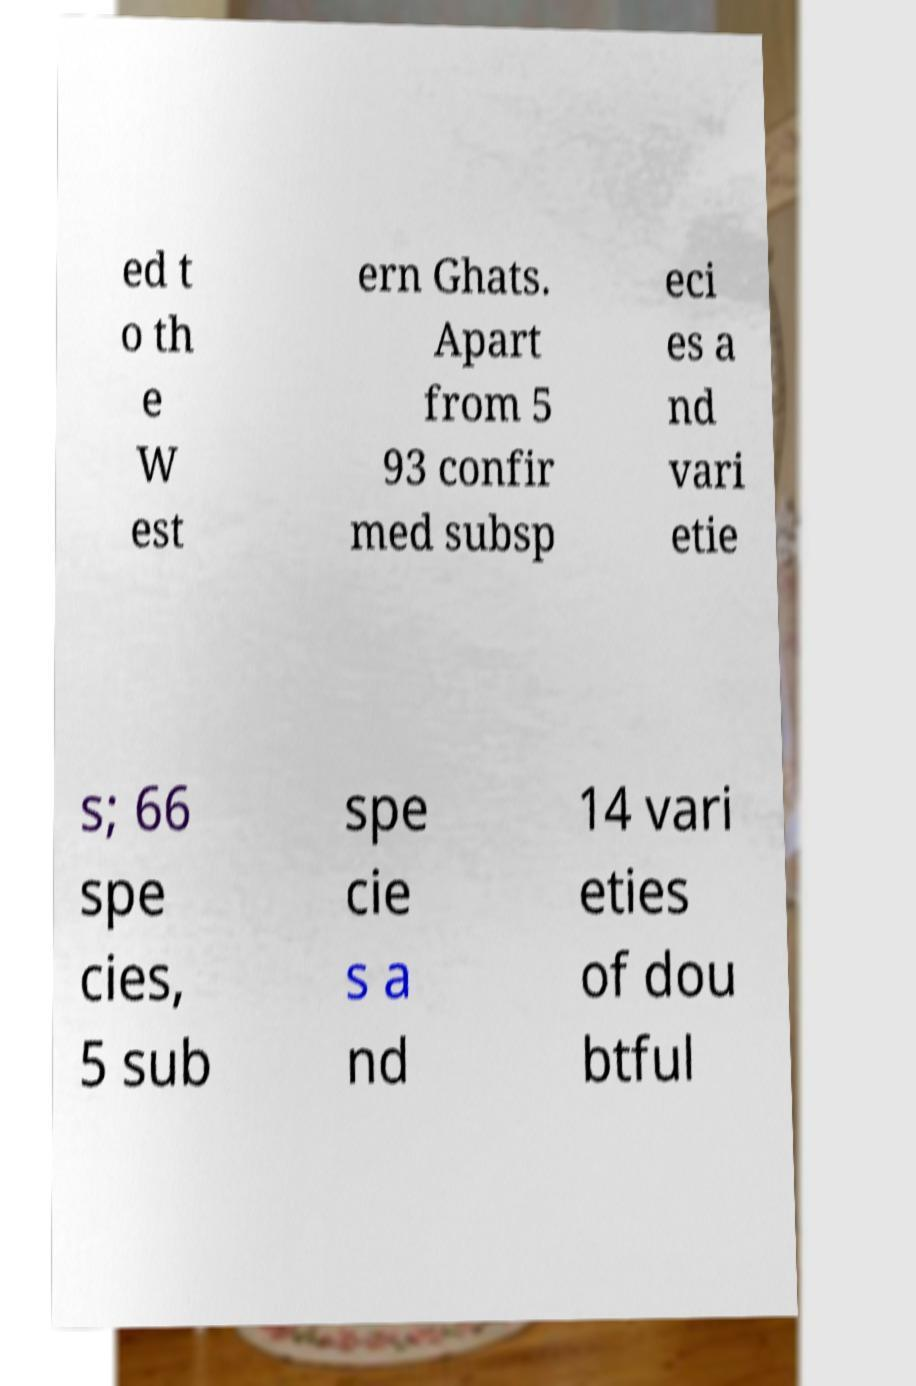For documentation purposes, I need the text within this image transcribed. Could you provide that? ed t o th e W est ern Ghats. Apart from 5 93 confir med subsp eci es a nd vari etie s; 66 spe cies, 5 sub spe cie s a nd 14 vari eties of dou btful 